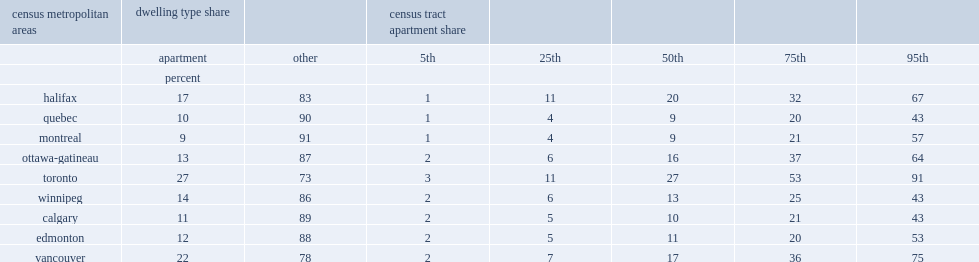Which metropolitan area has the highest share of families in apartment buildings? Toronto. Which metropolitan area has the lowest share of families in apartment buildings? Montreal. What was the share of families in apartments at the 95th percentile in toronto? 91.0. 